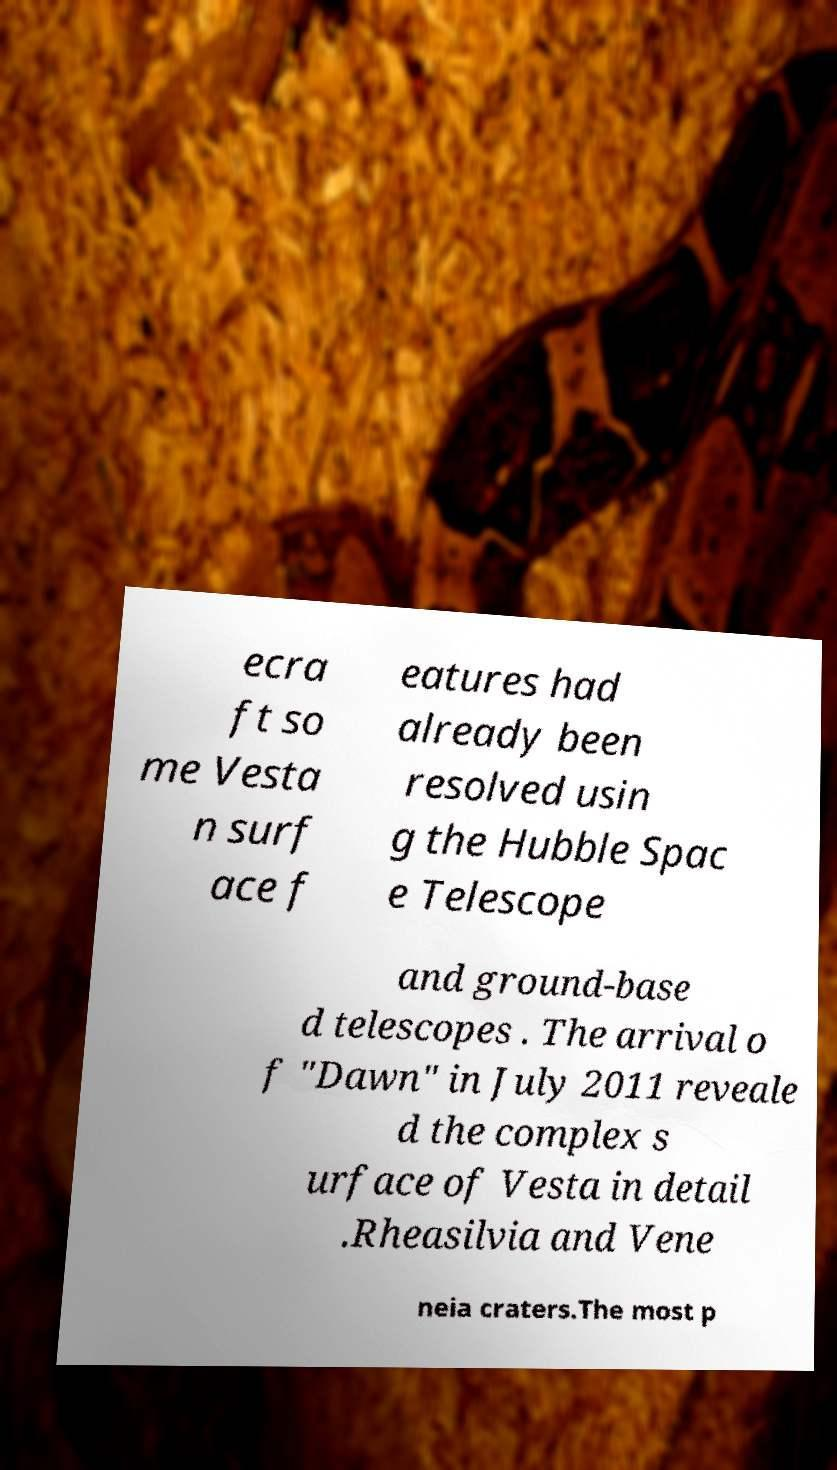Could you extract and type out the text from this image? ecra ft so me Vesta n surf ace f eatures had already been resolved usin g the Hubble Spac e Telescope and ground-base d telescopes . The arrival o f "Dawn" in July 2011 reveale d the complex s urface of Vesta in detail .Rheasilvia and Vene neia craters.The most p 